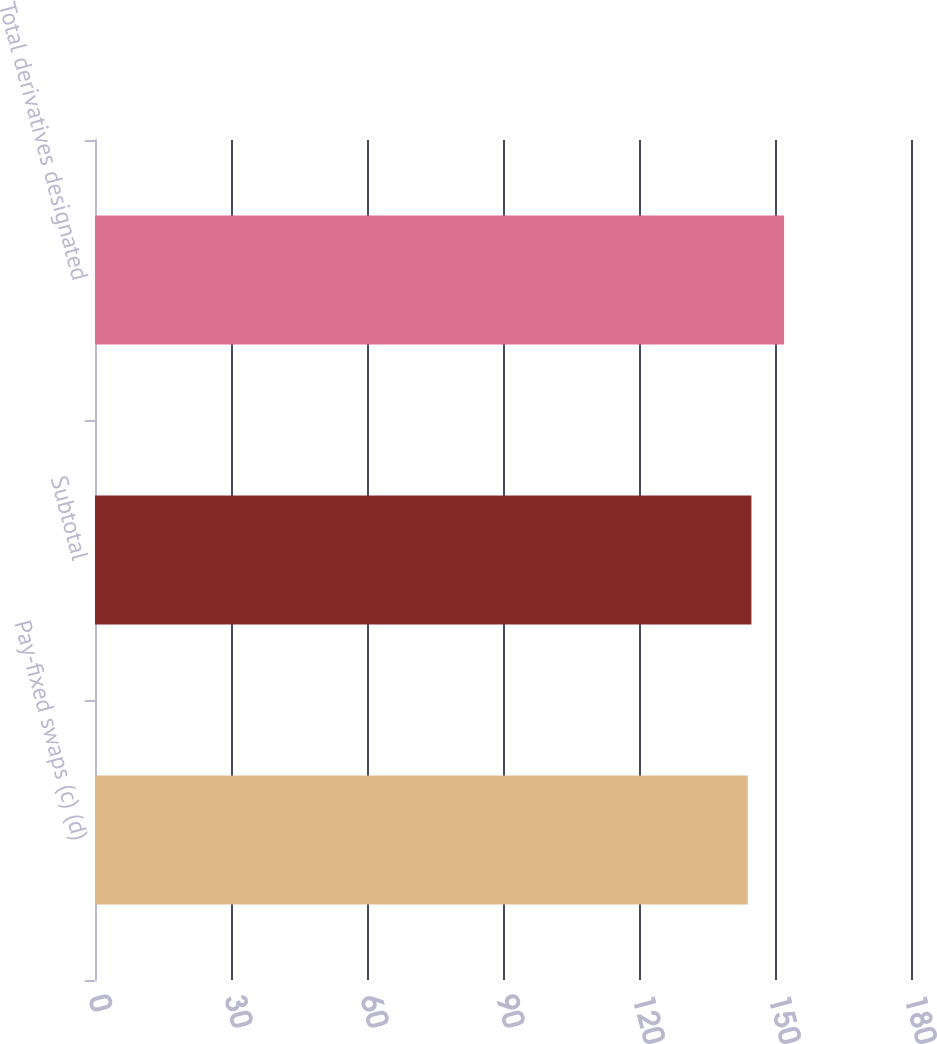<chart> <loc_0><loc_0><loc_500><loc_500><bar_chart><fcel>Pay-fixed swaps (c) (d)<fcel>Subtotal<fcel>Total derivatives designated<nl><fcel>144<fcel>144.8<fcel>152<nl></chart> 